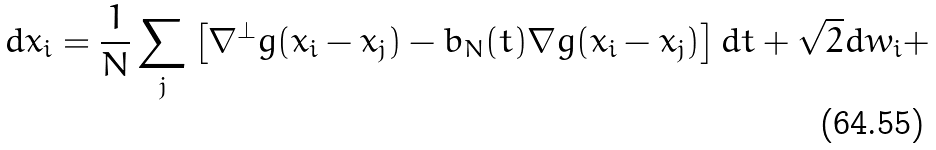<formula> <loc_0><loc_0><loc_500><loc_500>d x _ { i } = \frac { 1 } { N } \sum _ { j } \left [ \nabla ^ { \perp } g ( x _ { i } - x _ { j } ) - b _ { N } ( t ) \nabla g ( x _ { i } - x _ { j } ) \right ] d t + \sqrt { 2 } d w _ { i } +</formula> 